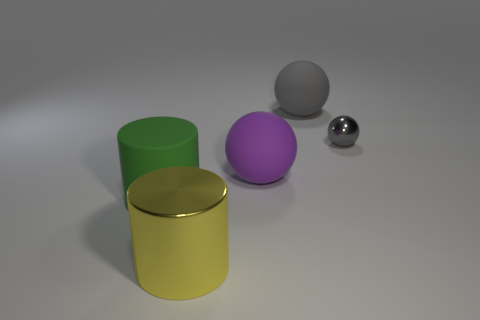Add 3 large green matte objects. How many objects exist? 8 Subtract all balls. How many objects are left? 2 Add 1 tiny gray balls. How many tiny gray balls exist? 2 Subtract 1 purple balls. How many objects are left? 4 Subtract all purple objects. Subtract all rubber things. How many objects are left? 1 Add 4 large gray things. How many large gray things are left? 5 